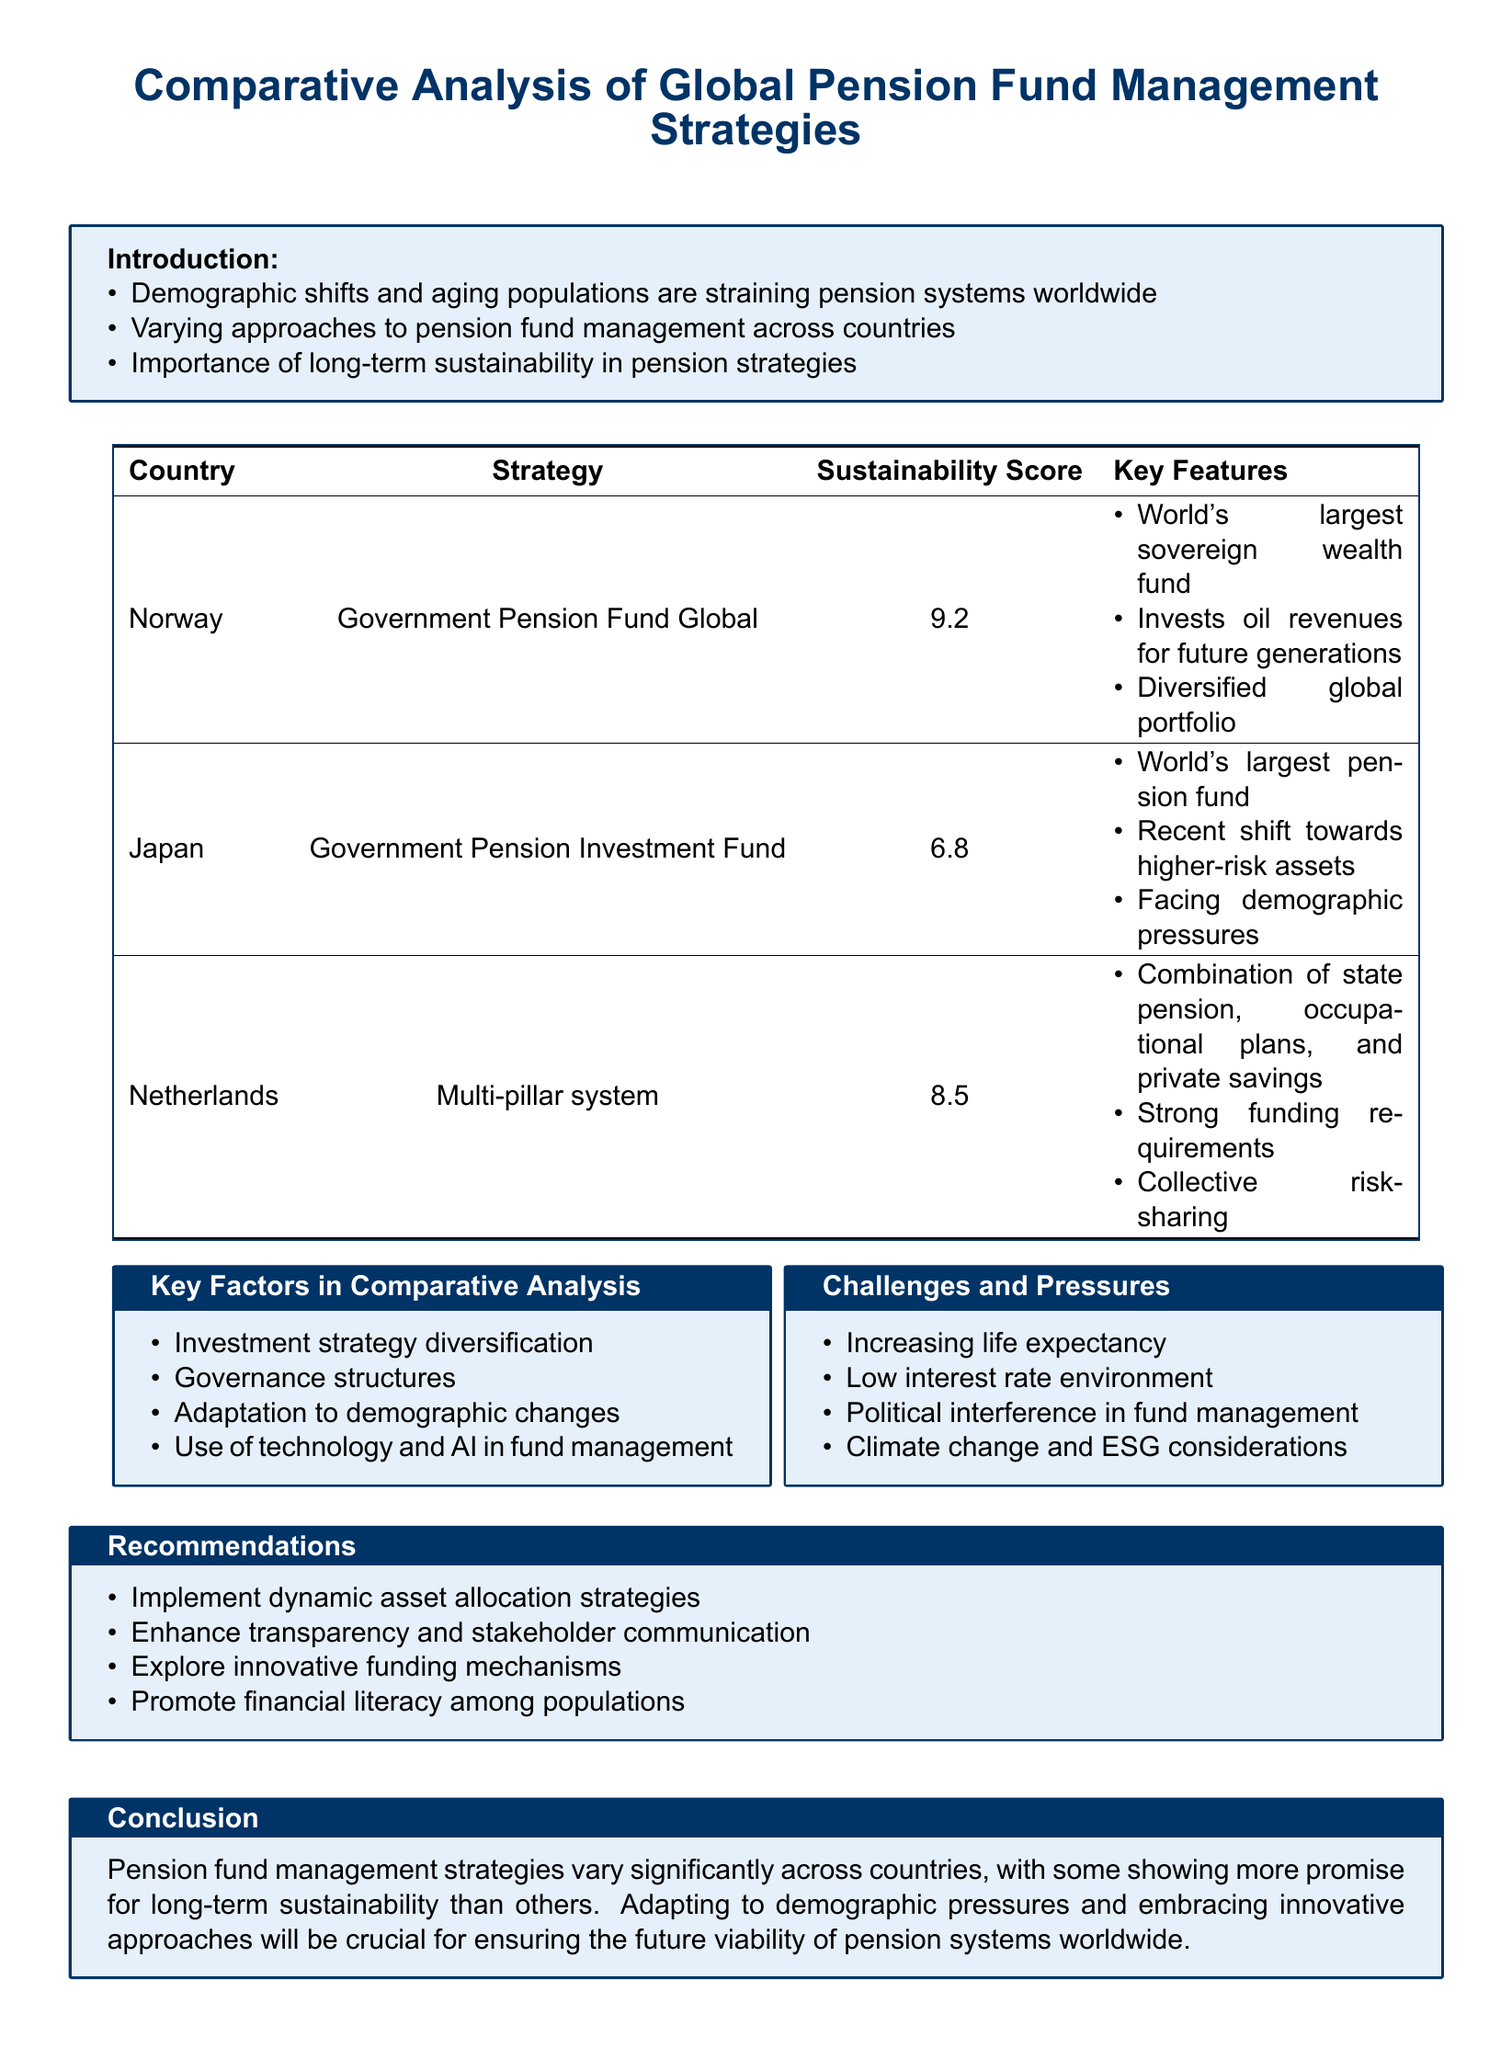What is the highest sustainability score? The highest sustainability score in the document is listed under Norway's pension strategy.
Answer: 9.2 Which country utilizes a multi-pillar system for pension management? The Netherlands employs a multi-pillar system, which combines different funding sources.
Answer: Netherlands What demographic challenge is mentioned in the report? Increasing life expectancy is cited as a significant challenge affecting pension systems.
Answer: Increasing life expectancy What is the strategy employed by Japan for its pension fund? Japan's strategy for pension management is the Government Pension Investment Fund (GPIF).
Answer: Government Pension Investment Fund Which key factor in comparative analysis involves the use of technology? The use of technology and AI in fund management is recognized as a key factor in the analysis.
Answer: Use of technology and AI in fund management What recommendation focuses on asset allocation? "Implement dynamic asset allocation strategies" is the recommendation related to asset allocation.
Answer: Implement dynamic asset allocation strategies What pressing issue related to fund management is mentioned due to climate change? The document references Climate change and ESG considerations as a pressing issue.
Answer: Climate change and ESG considerations Which country has the lowest sustainability score according to the report? The country with the lowest sustainability score, as outlined in the study, is Japan.
Answer: Japan What is the primary focus of the introduction section of the report? The primary focus of the introduction is the importance of long-term sustainability in pension strategies.
Answer: Importance of long-term sustainability in pension strategies 